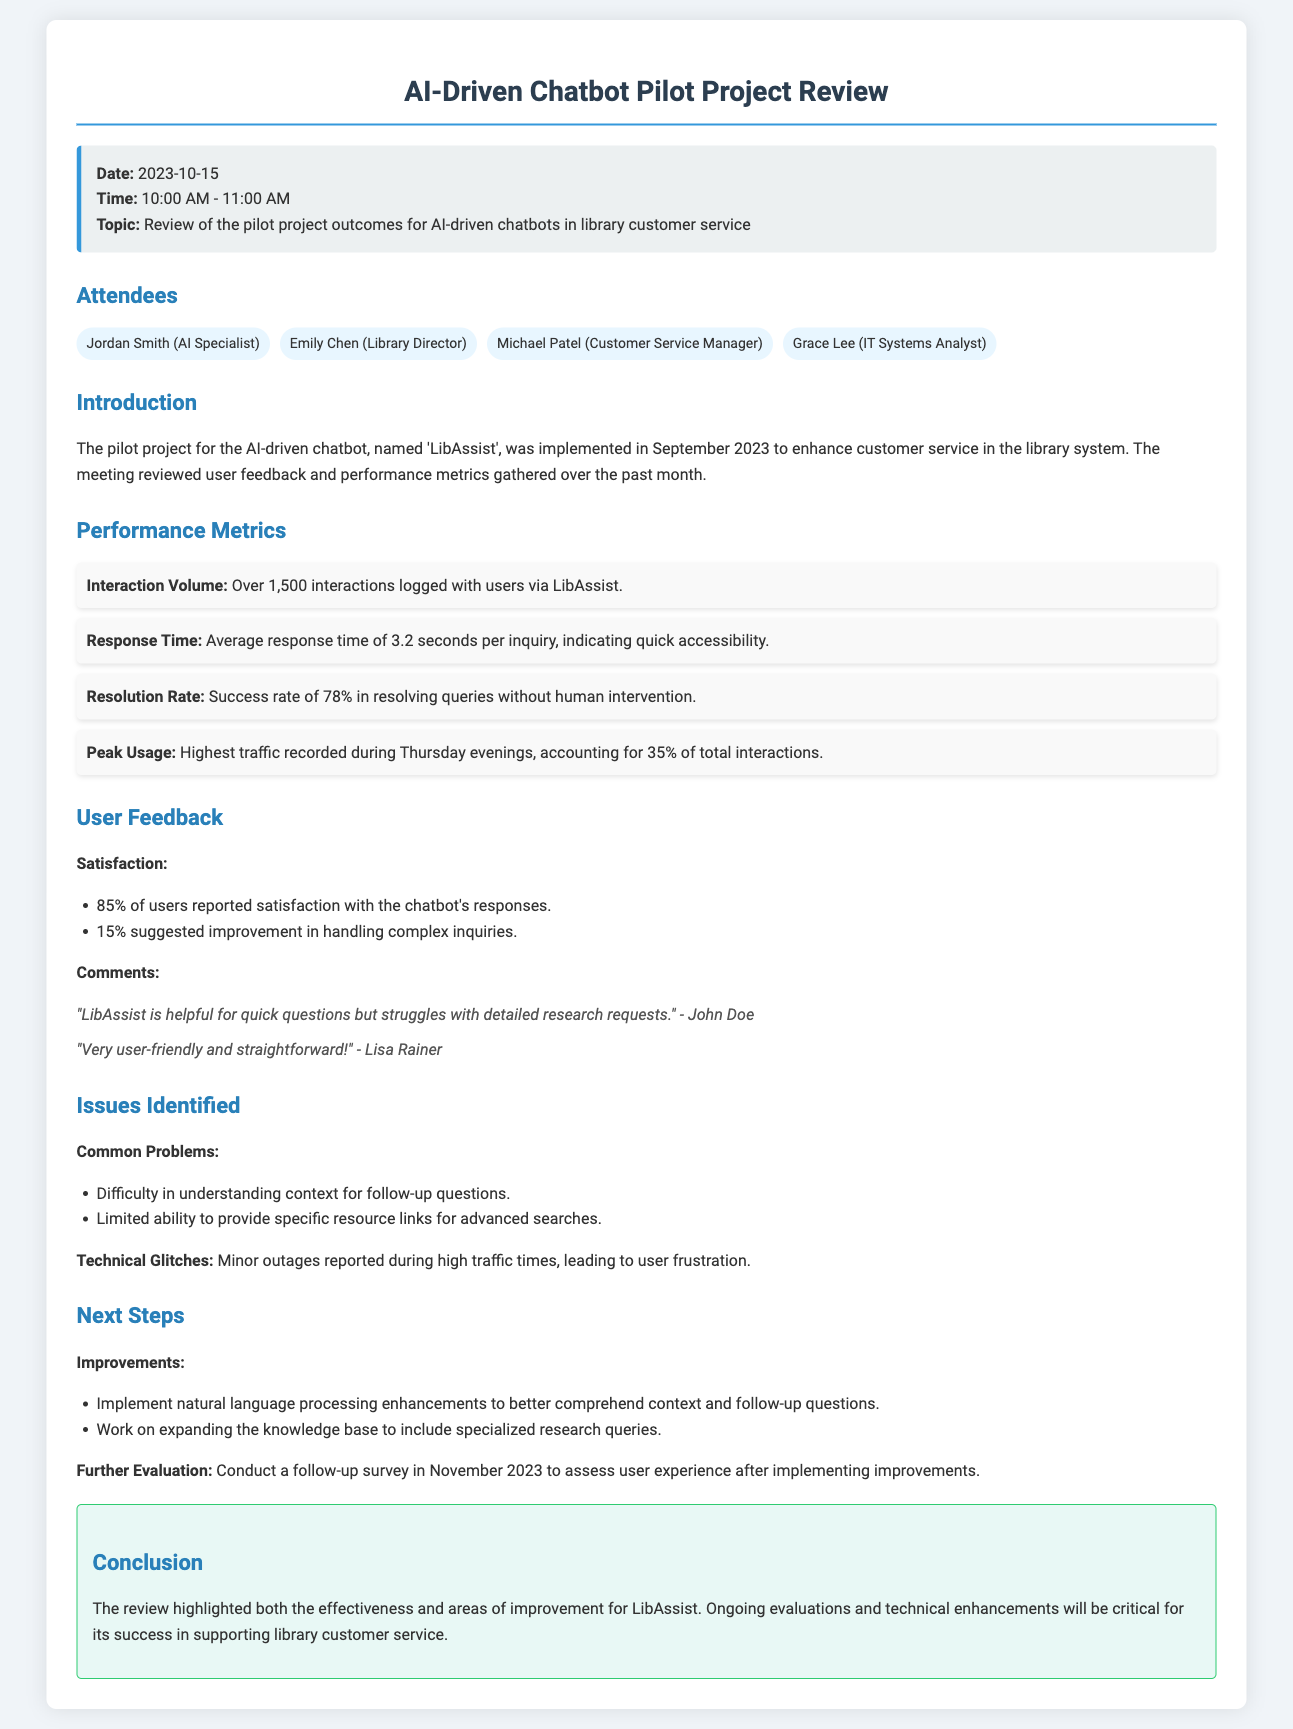What is the name of the chatbot? The chatbot is named 'LibAssist', as mentioned in the introduction section of the document.
Answer: LibAssist What was the average response time for inquiries? The average response time is mentioned in the performance metrics section as 3.2 seconds.
Answer: 3.2 seconds How many interactions were logged with users? The performance metrics state that over 1,500 interactions were logged with users.
Answer: Over 1,500 What percentage of users reported satisfaction with the chatbot's responses? The user feedback section reports that 85% of users reported satisfaction.
Answer: 85% What were the common problems identified? The issues identified were discussed in a bulleted list, which included understanding context for follow-up questions and limited ability to provide resource links.
Answer: Difficulty in understanding context for follow-up questions and limited ability to provide specific resource links for advanced searches What improvements are planned for the chatbot? The next steps highlighted enhancements to natural language processing and expanding the knowledge base.
Answer: Implement natural language processing enhancements and work on expanding the knowledge base On what day was the meeting held? The date of the meeting is specified in the info box at the beginning of the document as 2023-10-15.
Answer: 2023-10-15 What is the resolution rate of the chatbot? The performance metrics indicate a success rate of 78% in resolving queries without human intervention.
Answer: 78% How often did minor outages occur? Minor outages were reported during high traffic times, as stated in the issues identified section.
Answer: During high traffic times 